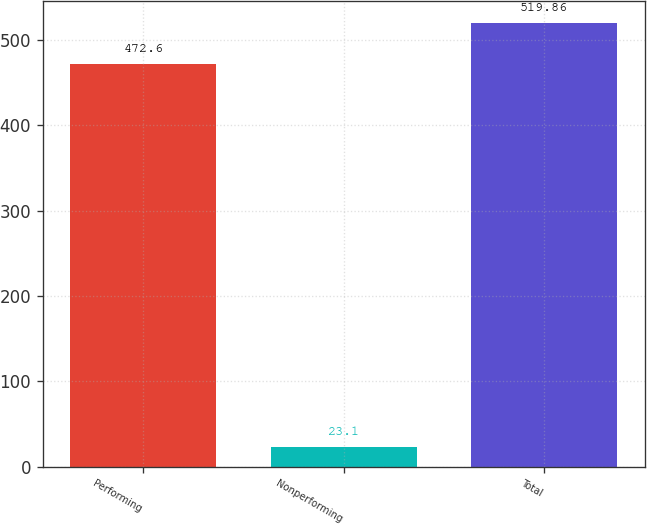Convert chart. <chart><loc_0><loc_0><loc_500><loc_500><bar_chart><fcel>Performing<fcel>Nonperforming<fcel>Total<nl><fcel>472.6<fcel>23.1<fcel>519.86<nl></chart> 